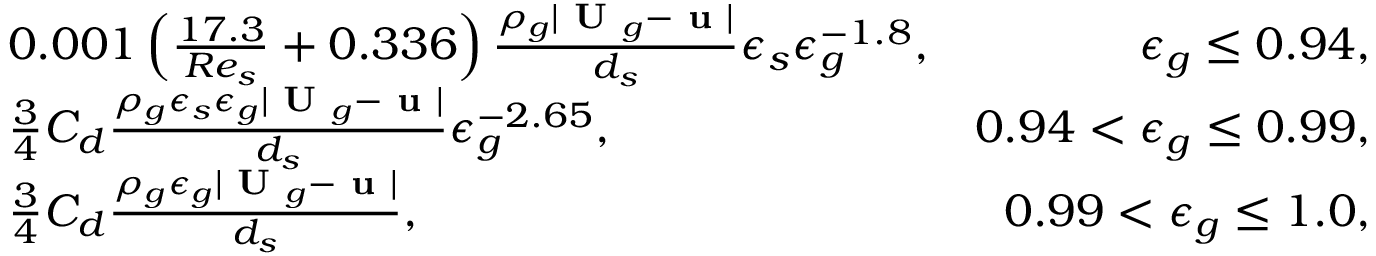<formula> <loc_0><loc_0><loc_500><loc_500>\begin{array} { r l r } & { 0 . 0 0 1 \left ( \frac { 1 7 . 3 } { R e _ { s } } + 0 . 3 3 6 \right ) \frac { \rho _ { g } | U _ { g } - u | } { d _ { s } } \epsilon _ { s } \epsilon _ { g } ^ { - 1 . 8 } , } & { \epsilon _ { g } \leq 0 . 9 4 , } \\ & { \frac { 3 } { 4 } C _ { d } \frac { \rho _ { g } \epsilon _ { s } \epsilon _ { g } | U _ { g } - u | } { d _ { s } } \epsilon _ { g } ^ { - 2 . 6 5 } , } & { 0 . 9 4 < \epsilon _ { g } \leq 0 . 9 9 , } \\ & { \frac { 3 } { 4 } C _ { d } \frac { \rho _ { g } \epsilon _ { g } | U _ { g } - u | } { d _ { s } } , } & { 0 . 9 9 < \epsilon _ { g } \leq 1 . 0 , } \end{array}</formula> 